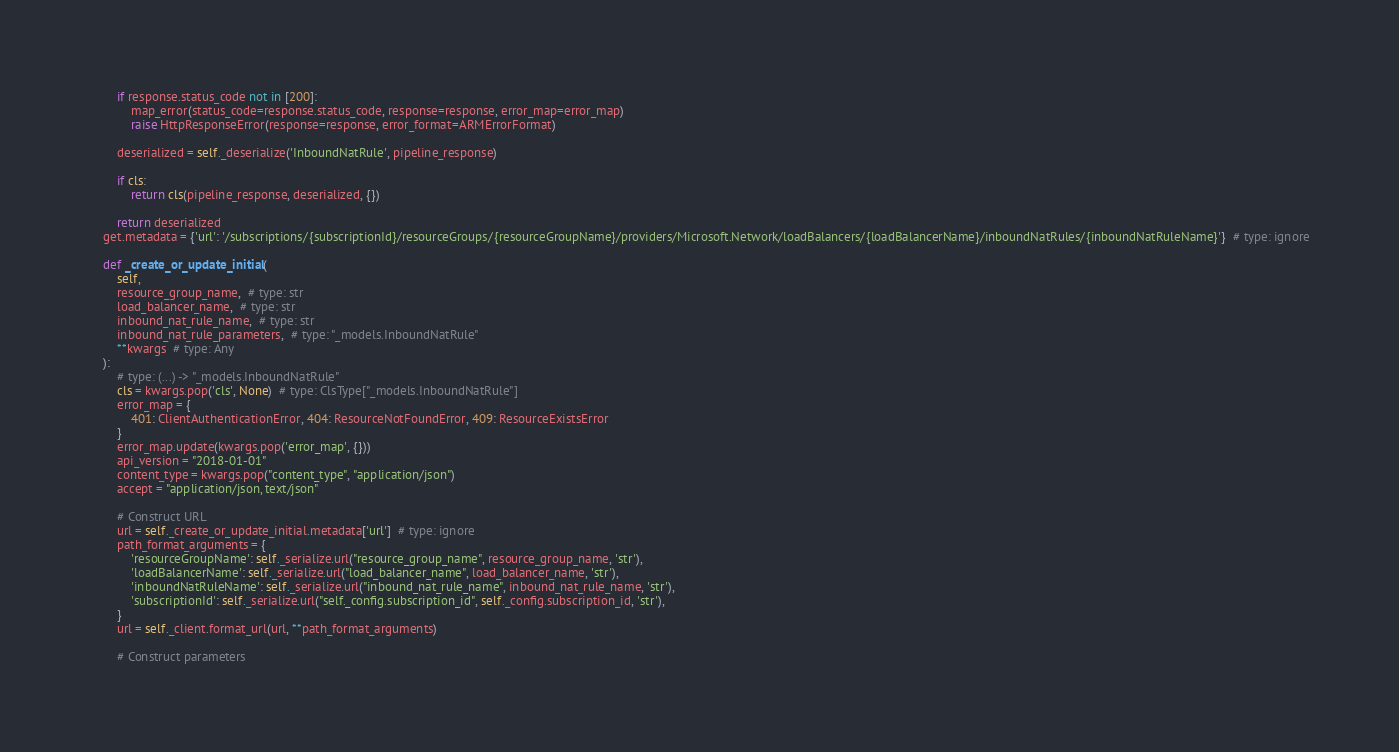<code> <loc_0><loc_0><loc_500><loc_500><_Python_>
        if response.status_code not in [200]:
            map_error(status_code=response.status_code, response=response, error_map=error_map)
            raise HttpResponseError(response=response, error_format=ARMErrorFormat)

        deserialized = self._deserialize('InboundNatRule', pipeline_response)

        if cls:
            return cls(pipeline_response, deserialized, {})

        return deserialized
    get.metadata = {'url': '/subscriptions/{subscriptionId}/resourceGroups/{resourceGroupName}/providers/Microsoft.Network/loadBalancers/{loadBalancerName}/inboundNatRules/{inboundNatRuleName}'}  # type: ignore

    def _create_or_update_initial(
        self,
        resource_group_name,  # type: str
        load_balancer_name,  # type: str
        inbound_nat_rule_name,  # type: str
        inbound_nat_rule_parameters,  # type: "_models.InboundNatRule"
        **kwargs  # type: Any
    ):
        # type: (...) -> "_models.InboundNatRule"
        cls = kwargs.pop('cls', None)  # type: ClsType["_models.InboundNatRule"]
        error_map = {
            401: ClientAuthenticationError, 404: ResourceNotFoundError, 409: ResourceExistsError
        }
        error_map.update(kwargs.pop('error_map', {}))
        api_version = "2018-01-01"
        content_type = kwargs.pop("content_type", "application/json")
        accept = "application/json, text/json"

        # Construct URL
        url = self._create_or_update_initial.metadata['url']  # type: ignore
        path_format_arguments = {
            'resourceGroupName': self._serialize.url("resource_group_name", resource_group_name, 'str'),
            'loadBalancerName': self._serialize.url("load_balancer_name", load_balancer_name, 'str'),
            'inboundNatRuleName': self._serialize.url("inbound_nat_rule_name", inbound_nat_rule_name, 'str'),
            'subscriptionId': self._serialize.url("self._config.subscription_id", self._config.subscription_id, 'str'),
        }
        url = self._client.format_url(url, **path_format_arguments)

        # Construct parameters</code> 